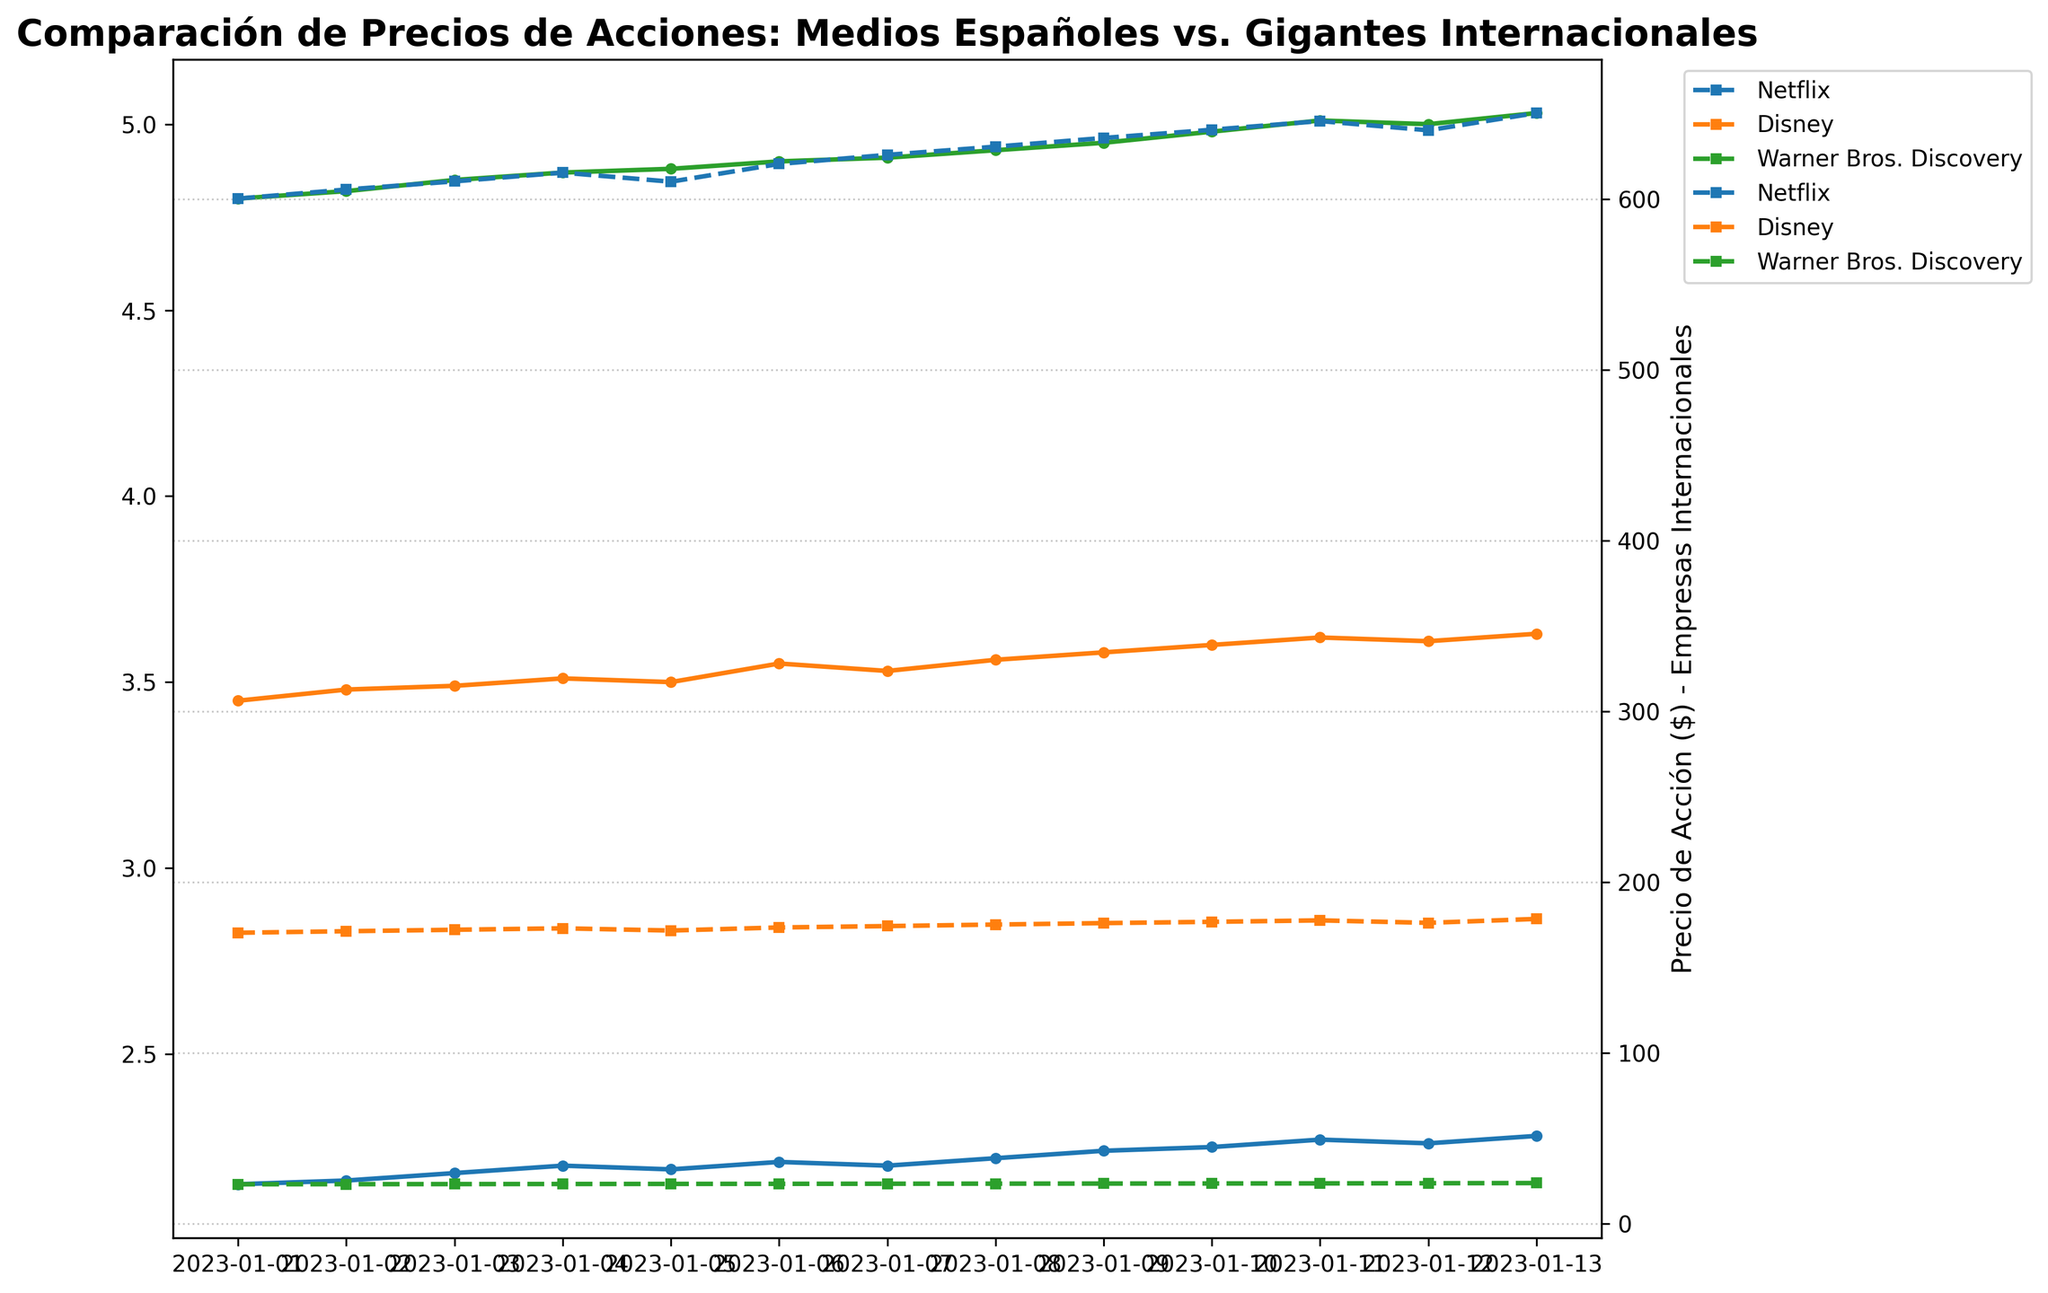Which company has the highest stock price on 2023-01-01? On 2023-01-01, the stock prices are displayed for all companies. By looking at the figure, note that Netflix has a significantly higher stock price than the other companies.
Answer: Netflix What is the general trend for Grupo Prisa's stock price over the given dates? Observe the plotted line for Grupo Prisa from 2023-01-01 to 2023-01-13. The stock price generally increases over the period, starting at 2.15 and ending at 2.28.
Answer: Increasing Between Atresmedia and Mediaset España, which company had a higher stock price on 2023-01-05? Look at the stock prices for both companies on 2023-01-05. Atresmedia's price is approximately 3.50, whereas Mediaset España's price is roughly 4.88, making Mediaset España higher.
Answer: Mediaset España What is the difference in stock price for Netflix between 2023-01-01 and 2023-01-13? Locate Netflix's stock price on 2023-01-01 and 2023-01-13. The prices are 600.20 and 650.30 respectively. The difference is calculated as 650.30 - 600.20.
Answer: 50.10 What is the average stock price of Atresmedia over the given dates? Identify Atresmedia's stock prices from 2023-01-01 to 2023-01-13, then sum them up (3.45 + 3.48 + 3.49 + 3.51 + 3.50 + 3.55 + 3.53 + 3.56 + 3.58 + 3.60 + 3.62 + 3.61 + 3.63 = 45.11). There are 13 data points, so the average is 45.11 / 13.
Answer: 3.47 Which company shows the most stability in its stock price over the given period? Stability in stock price can be observed through minimal fluctuations. Comparing the plotted lines, Warner Bros. Discovery shows relatively less variation compared to others, remaining around the 23.10-23.80 range.
Answer: Warner Bros. Discovery How did the stock prices of Disney change from 2023-01-05 to 2023-01-11? Look at Disney's prices on 2023-01-05 (171.65) and 2023-01-11 (177.60). Notice the trajectory in between, indicating an overall increase.
Answer: Increased On which date did Mediaset España's stock price reach 5.00 for the first time? Follow the plotted line for Mediaset España and identify the exact date when the price first hits 5.00. It happens on 2023-01-12.
Answer: 2023-01-12 Is there any point where the stock price of Netflix decreased significantly? Trace the line for Netflix and observe the price changes. Notice that while there are some fluctuations, there is no significant decrease within the given dates.
Answer: No significant decrease 